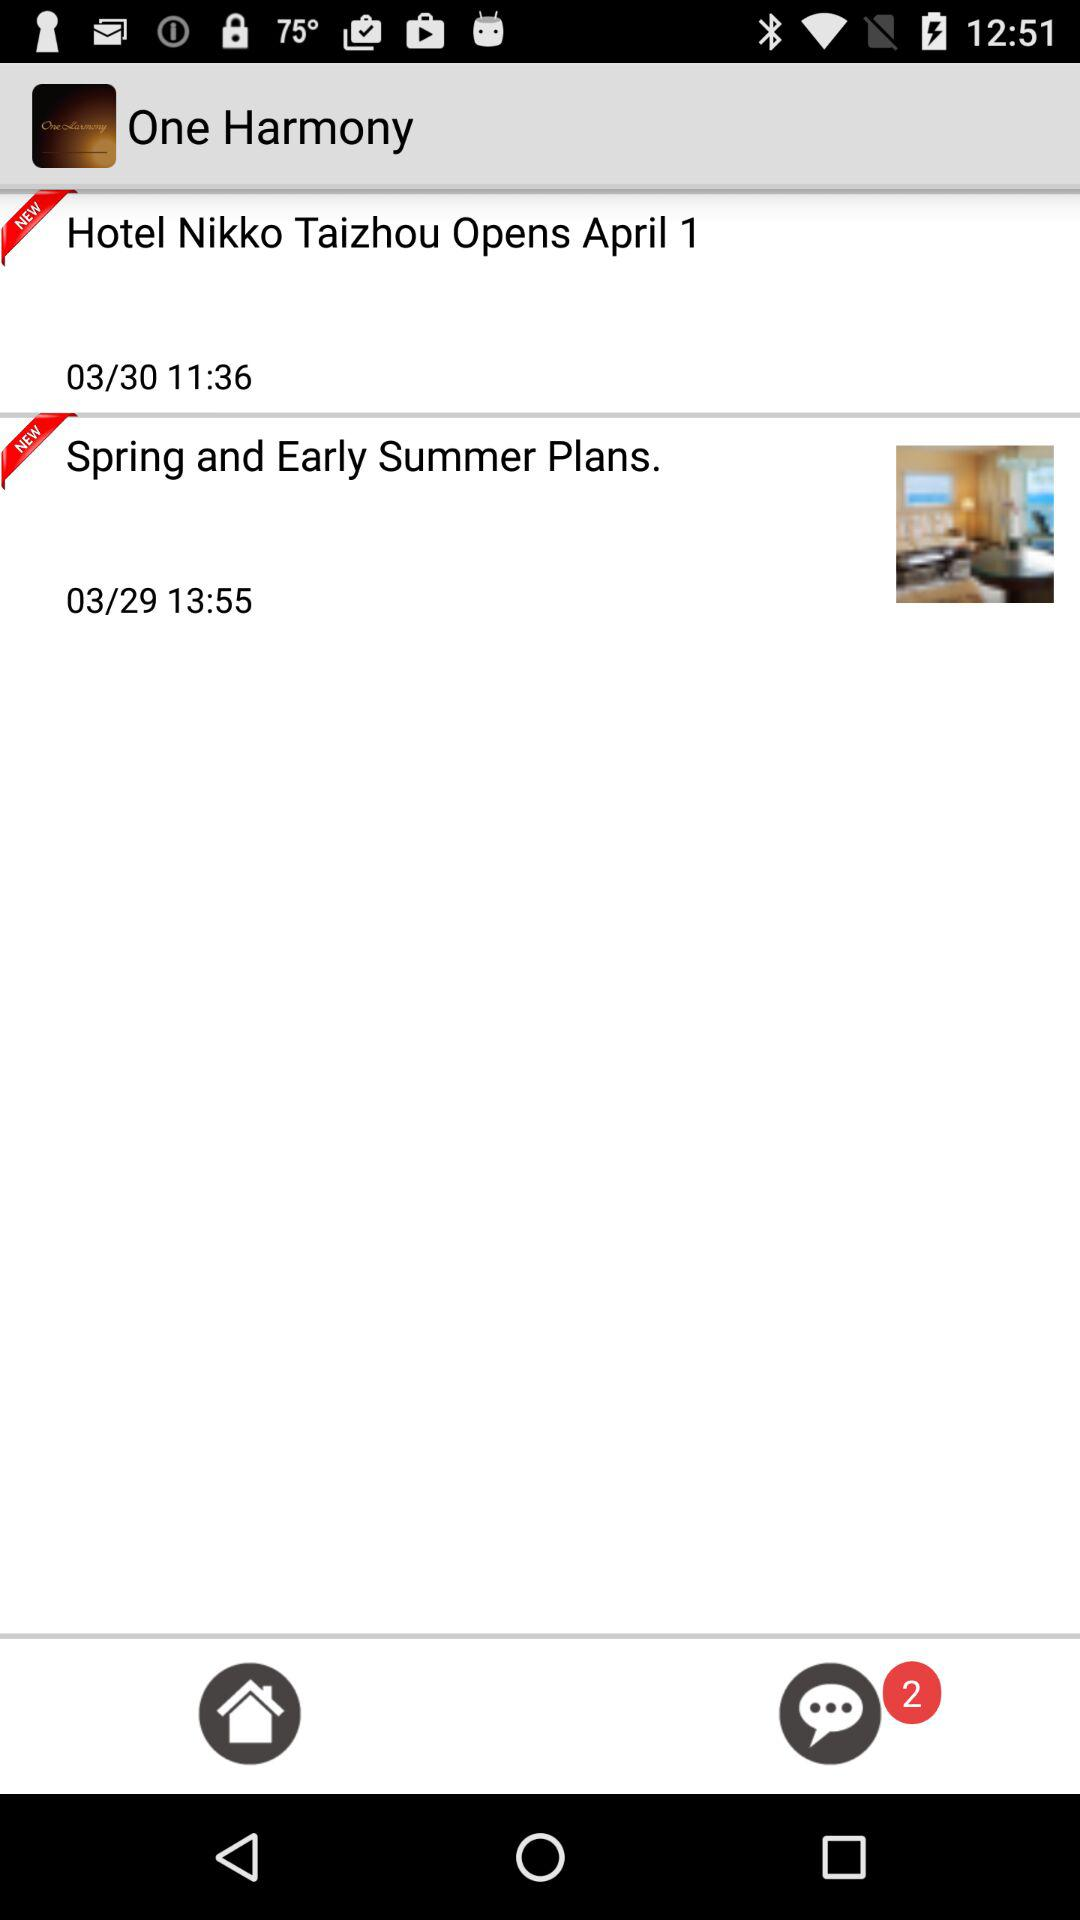How many unread items are there in total?
Answer the question using a single word or phrase. 2 